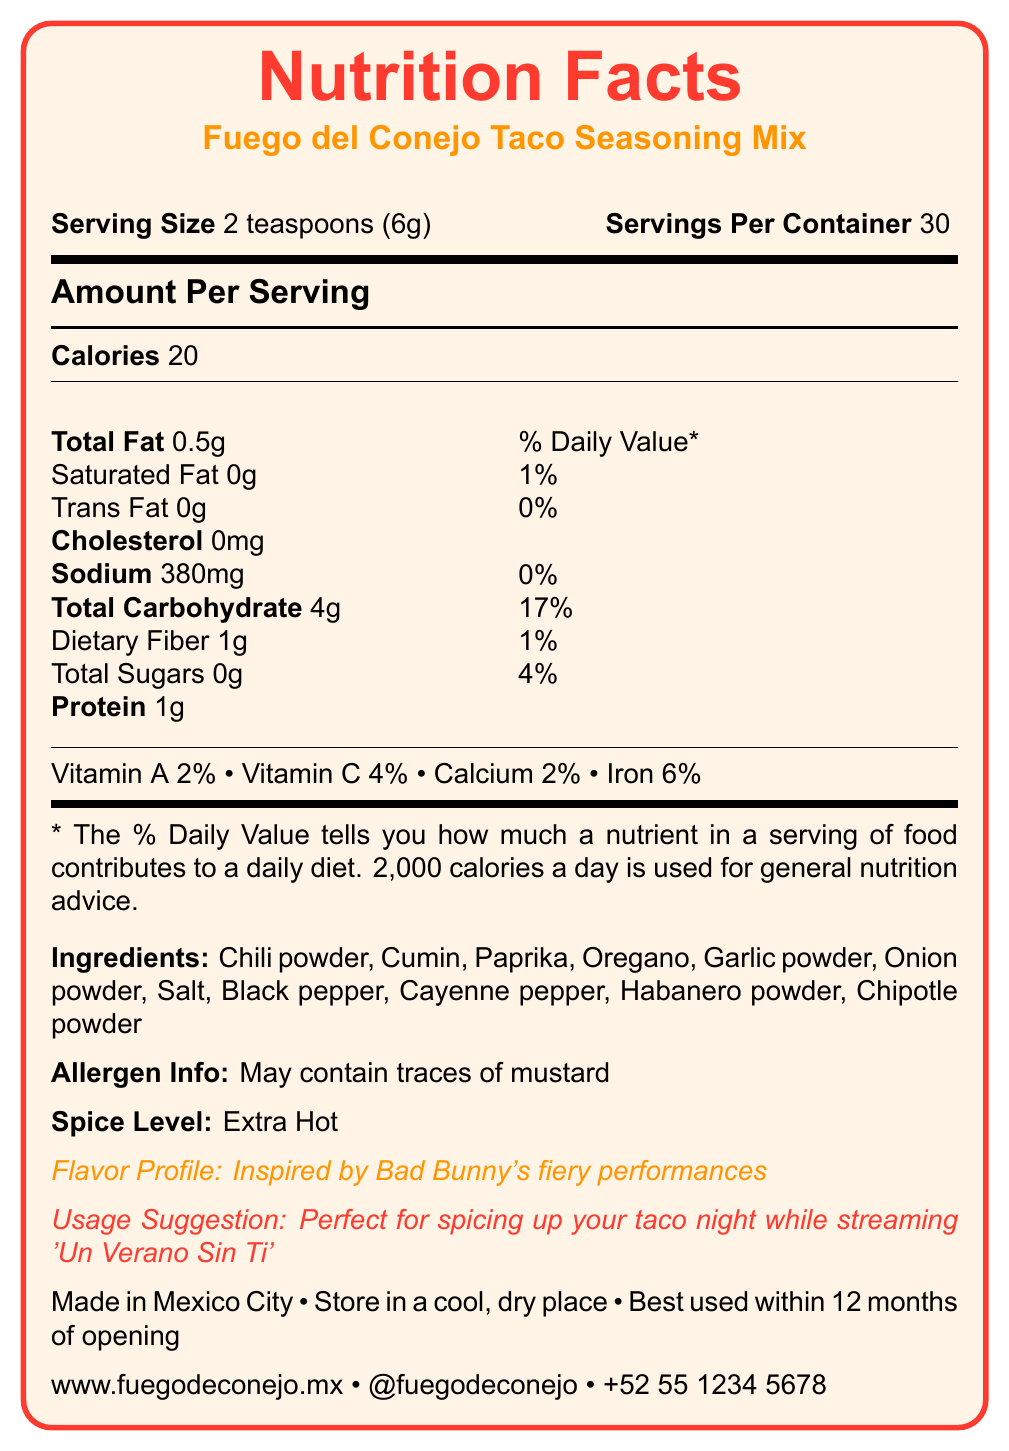what is the name of the product? The name of the product is explicitly stated in the Nutrition Facts Label.
Answer: Fuego del Conejo Taco Seasoning Mix how many servings are in one container? The label states that there are 30 servings per container.
Answer: 30 how many calories are in one serving? The label indicates that there are 20 calories per serving.
Answer: 20 how much sodium does one serving contain? The number of milligrams of sodium per serving is listed as 380mg.
Answer: 380mg what is the percentage of daily value for iron in one serving? The label specifies that the percentage of daily value for iron in one serving is 6%.
Answer: 6% which spices are listed as ingredients in the seasoning mix? The label provides a list of ingredients including these spices.
Answer: Chili powder, Cumin, Paprika, Oregano, Garlic powder, Onion powder, Salt, Black pepper, Cayenne pepper, Habanero powder, Chipotle powder what is the spice level of this seasoning mix? The label indicates that the spice level is Extra Hot.
Answer: Extra Hot where is this seasoning mix made? The document states that the seasoning mix is made in Mexico City.
Answer: Mexico City how should the product be stored? The label advises storing the product in a cool, dry place away from direct sunlight.
Answer: Store in a cool, dry place away from direct sunlight what is the recommended usage suggestion for this seasoning? The label suggests using the seasoning mix to spice up taco night while streaming 'Un Verano Sin Ti'.
Answer: Perfect for spicing up your taco night while streaming 'Un Verano Sin Ti' which type of pepper contributes to the "Extra Hot" spice level? A. Jalapeño B. Habanero C. Bell pepper D. Serrano The ingredient list includes habanero powder which contributes to the Extra Hot spice level.
Answer: B. Habanero what percentage of the daily value of Vitamin C does one serving provide? A. 2% B. 4% C. 6% D. 8% The daily value for Vitamin C per serving is 4%, as mentioned on the label.
Answer: B. 4% what is the main flavor profile of this taco seasoning mix? The label describes the flavor profile as being inspired by Bad Bunny's fiery performances.
Answer: Inspired by Bad Bunny's fiery performances does the seasoning mix contain any sugars? The label states that the total sugars per serving are 0g.
Answer: No is there any allergen information provided? The label mentions that the product may contain traces of mustard.
Answer: Yes summarize the main information included in the Nutrition Facts Label. The explanation gives a comprehensive overview of all the pieces of information provided by the Nutrition Facts Label including nutritional values, ingredient list, additional product details, and contact information.
Answer: This label provides nutritional information for the Fuego del Conejo Taco Seasoning Mix, specifying its serving size, number of servings, calorie count, and nutritional content such as fats, sodium, carbohydrates, and protein. It also lists vitamins and minerals, ingredients, allergen information, spice level, flavor profile, usage suggestion, origin, storage instructions, expiration date, website, social media handle, and customer service contact number. what is the current price of the seasoning mix? The label does not provide any information regarding the price of the product.
Answer: Cannot be determined 